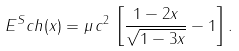Convert formula to latex. <formula><loc_0><loc_0><loc_500><loc_500>E ^ { S } c h ( x ) = \mu \, c ^ { 2 } \, \left [ \frac { 1 - 2 x } { \sqrt { 1 - 3 x } } - 1 \right ] .</formula> 